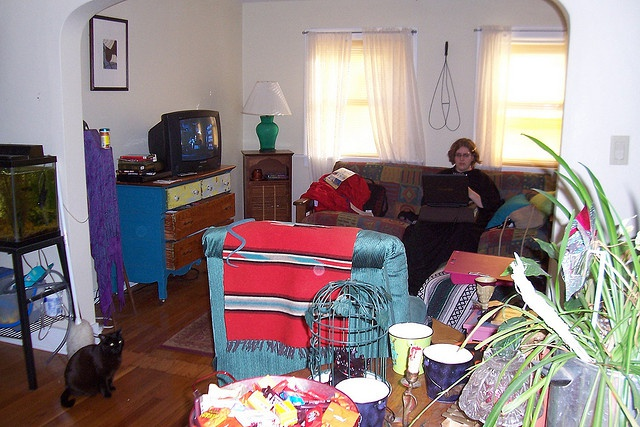Describe the objects in this image and their specific colors. I can see potted plant in darkgray, white, lightgreen, and gray tones, chair in darkgray, brown, teal, black, and gray tones, couch in darkgray, maroon, black, and gray tones, people in darkgray, black, maroon, and brown tones, and bowl in darkgray, white, khaki, lightpink, and salmon tones in this image. 